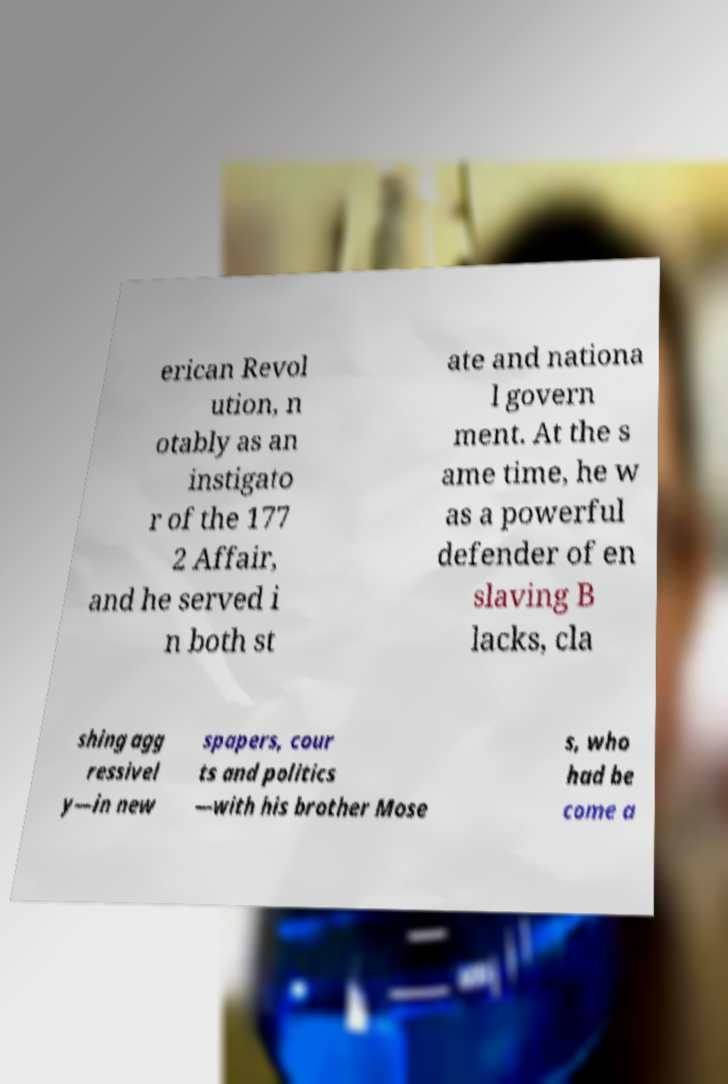Please read and relay the text visible in this image. What does it say? erican Revol ution, n otably as an instigato r of the 177 2 Affair, and he served i n both st ate and nationa l govern ment. At the s ame time, he w as a powerful defender of en slaving B lacks, cla shing agg ressivel y—in new spapers, cour ts and politics —with his brother Mose s, who had be come a 